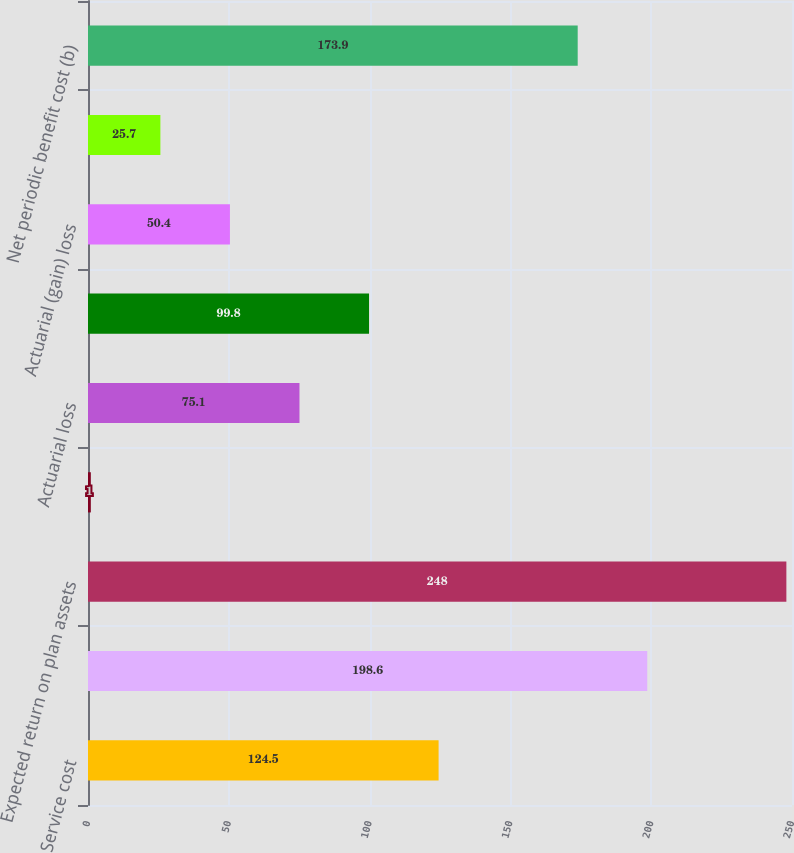Convert chart. <chart><loc_0><loc_0><loc_500><loc_500><bar_chart><fcel>Service cost<fcel>Interest cost<fcel>Expected return on plan assets<fcel>Prior service credit<fcel>Actuarial loss<fcel>Net periodic benefit cost<fcel>Actuarial (gain) loss<fcel>Curtailment gain<fcel>Net periodic benefit cost (b)<nl><fcel>124.5<fcel>198.6<fcel>248<fcel>1<fcel>75.1<fcel>99.8<fcel>50.4<fcel>25.7<fcel>173.9<nl></chart> 